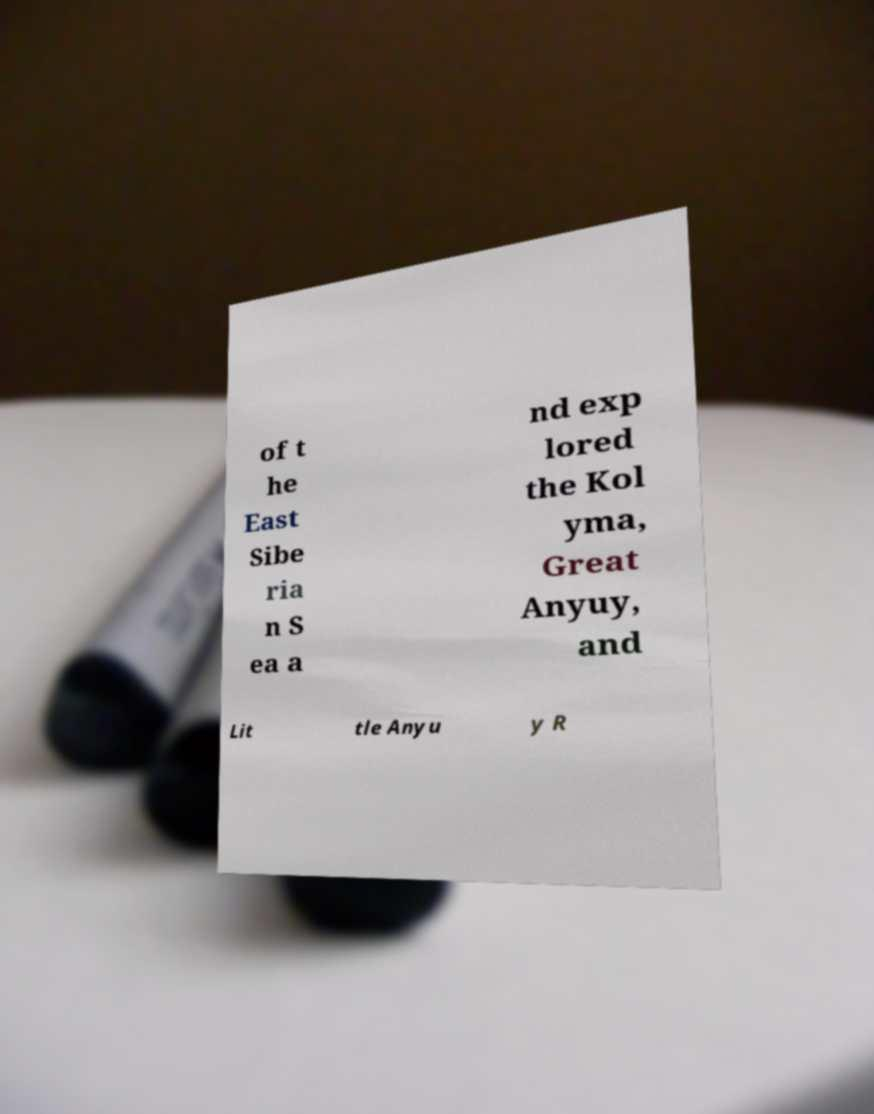What messages or text are displayed in this image? I need them in a readable, typed format. of t he East Sibe ria n S ea a nd exp lored the Kol yma, Great Anyuy, and Lit tle Anyu y R 